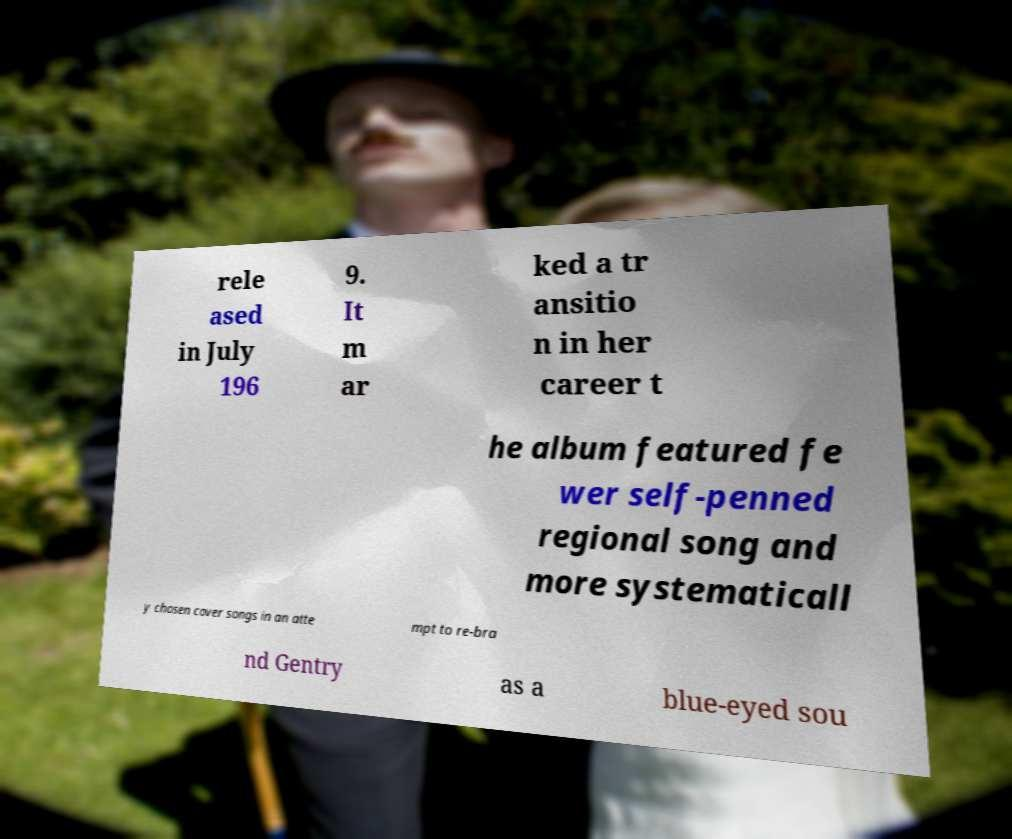What messages or text are displayed in this image? I need them in a readable, typed format. rele ased in July 196 9. It m ar ked a tr ansitio n in her career t he album featured fe wer self-penned regional song and more systematicall y chosen cover songs in an atte mpt to re-bra nd Gentry as a blue-eyed sou 